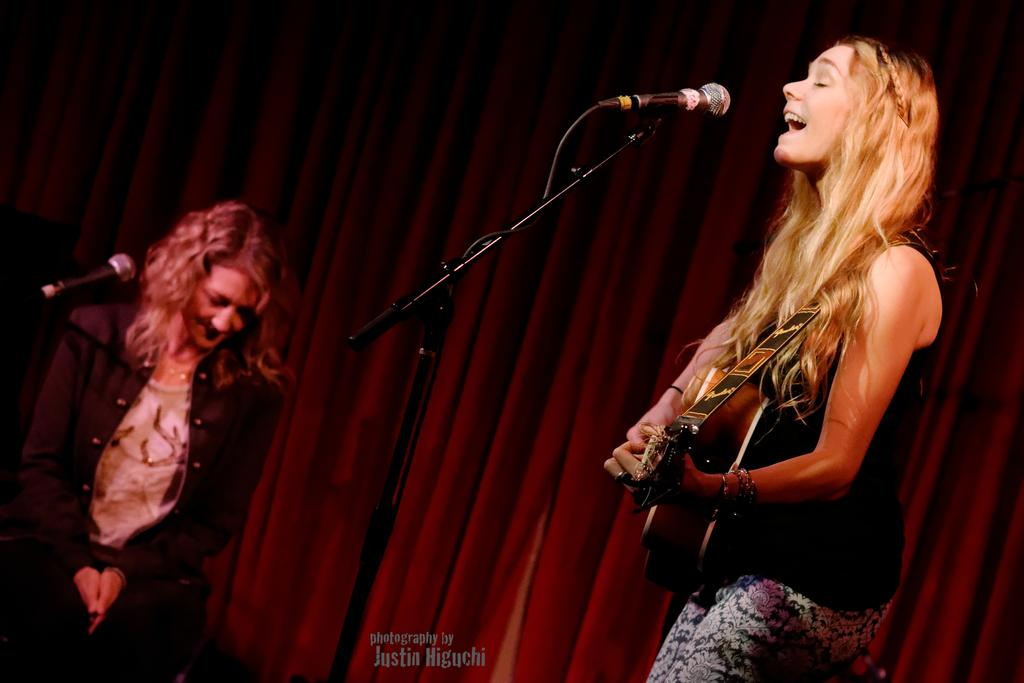How many people are in the image? There are two persons in the image. What are the persons doing in the image? The persons are standing and holding guitars. What is the facial expression of the persons in the image? The persons are smiling. What can be seen in the background of the image? There is a curtain in the background of the image. What type of tramp is visible in the image? There is no tramp present in the image. What selection of neckties can be seen on the persons in the image? The persons in the image are not wearing neckties, so there is no selection to observe. 